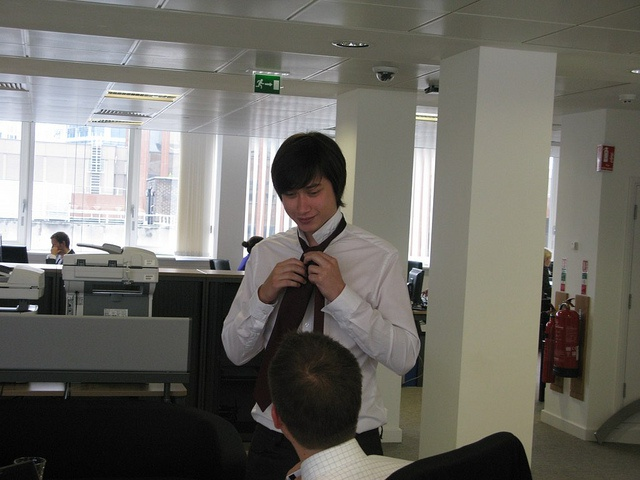Describe the objects in this image and their specific colors. I can see people in gray and black tones, people in gray, black, darkgray, and maroon tones, chair in gray and black tones, tie in gray and black tones, and people in gray and black tones in this image. 